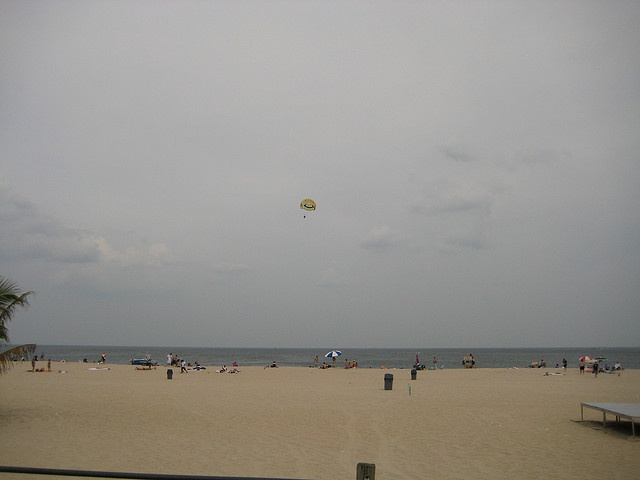Describe the objects in this image and their specific colors. I can see people in darkgray, gray, and black tones, kite in darkgray, olive, and gray tones, people in darkgray, black, gray, and maroon tones, umbrella in darkgray, navy, gray, and beige tones, and people in darkgray, black, gray, maroon, and brown tones in this image. 